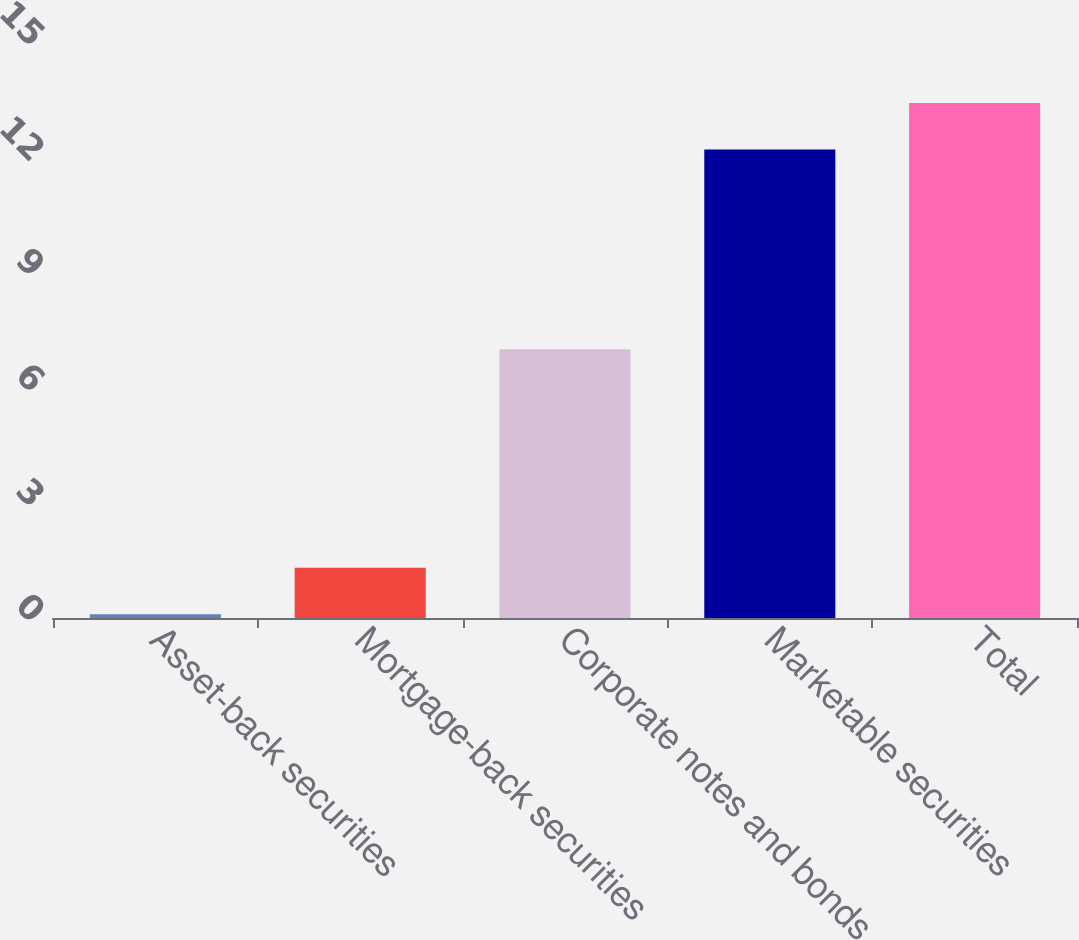<chart> <loc_0><loc_0><loc_500><loc_500><bar_chart><fcel>Asset-back securities<fcel>Mortgage-back securities<fcel>Corporate notes and bonds<fcel>Marketable securities<fcel>Total<nl><fcel>0.1<fcel>1.31<fcel>7<fcel>12.2<fcel>13.41<nl></chart> 